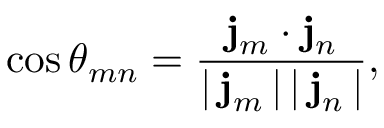Convert formula to latex. <formula><loc_0><loc_0><loc_500><loc_500>\cos \theta _ { m n } = \frac { { j } _ { m } \cdot { j } _ { n } } { | \, { j } _ { m } \, | \, | \, { j } _ { n } \, | } ,</formula> 